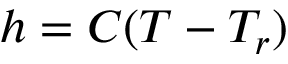Convert formula to latex. <formula><loc_0><loc_0><loc_500><loc_500>h = C ( T - T _ { r } )</formula> 